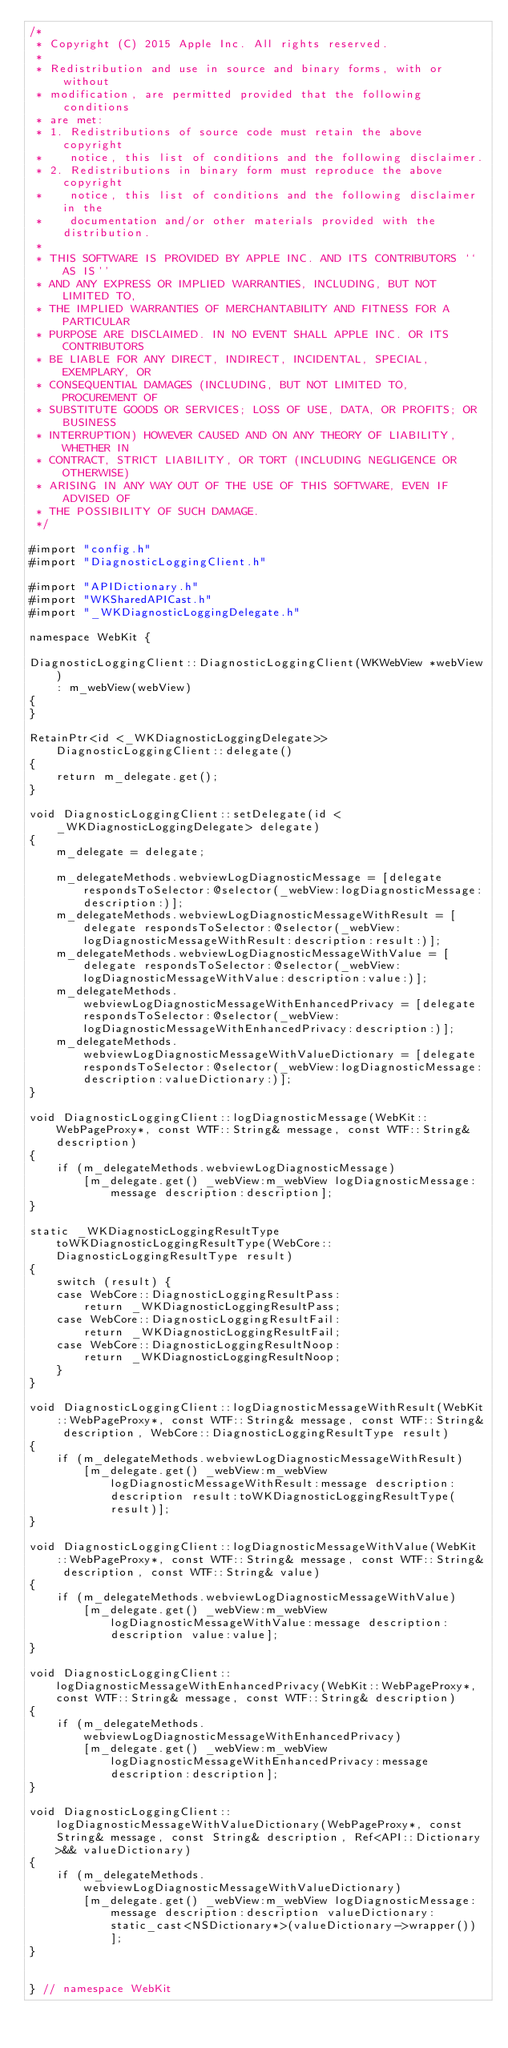<code> <loc_0><loc_0><loc_500><loc_500><_ObjectiveC_>/*
 * Copyright (C) 2015 Apple Inc. All rights reserved.
 *
 * Redistribution and use in source and binary forms, with or without
 * modification, are permitted provided that the following conditions
 * are met:
 * 1. Redistributions of source code must retain the above copyright
 *    notice, this list of conditions and the following disclaimer.
 * 2. Redistributions in binary form must reproduce the above copyright
 *    notice, this list of conditions and the following disclaimer in the
 *    documentation and/or other materials provided with the distribution.
 *
 * THIS SOFTWARE IS PROVIDED BY APPLE INC. AND ITS CONTRIBUTORS ``AS IS''
 * AND ANY EXPRESS OR IMPLIED WARRANTIES, INCLUDING, BUT NOT LIMITED TO,
 * THE IMPLIED WARRANTIES OF MERCHANTABILITY AND FITNESS FOR A PARTICULAR
 * PURPOSE ARE DISCLAIMED. IN NO EVENT SHALL APPLE INC. OR ITS CONTRIBUTORS
 * BE LIABLE FOR ANY DIRECT, INDIRECT, INCIDENTAL, SPECIAL, EXEMPLARY, OR
 * CONSEQUENTIAL DAMAGES (INCLUDING, BUT NOT LIMITED TO, PROCUREMENT OF
 * SUBSTITUTE GOODS OR SERVICES; LOSS OF USE, DATA, OR PROFITS; OR BUSINESS
 * INTERRUPTION) HOWEVER CAUSED AND ON ANY THEORY OF LIABILITY, WHETHER IN
 * CONTRACT, STRICT LIABILITY, OR TORT (INCLUDING NEGLIGENCE OR OTHERWISE)
 * ARISING IN ANY WAY OUT OF THE USE OF THIS SOFTWARE, EVEN IF ADVISED OF
 * THE POSSIBILITY OF SUCH DAMAGE.
 */

#import "config.h"
#import "DiagnosticLoggingClient.h"

#import "APIDictionary.h"
#import "WKSharedAPICast.h"
#import "_WKDiagnosticLoggingDelegate.h"

namespace WebKit {

DiagnosticLoggingClient::DiagnosticLoggingClient(WKWebView *webView)
    : m_webView(webView)
{
}

RetainPtr<id <_WKDiagnosticLoggingDelegate>> DiagnosticLoggingClient::delegate()
{
    return m_delegate.get();
}

void DiagnosticLoggingClient::setDelegate(id <_WKDiagnosticLoggingDelegate> delegate)
{
    m_delegate = delegate;

    m_delegateMethods.webviewLogDiagnosticMessage = [delegate respondsToSelector:@selector(_webView:logDiagnosticMessage:description:)];
    m_delegateMethods.webviewLogDiagnosticMessageWithResult = [delegate respondsToSelector:@selector(_webView:logDiagnosticMessageWithResult:description:result:)];
    m_delegateMethods.webviewLogDiagnosticMessageWithValue = [delegate respondsToSelector:@selector(_webView:logDiagnosticMessageWithValue:description:value:)];
    m_delegateMethods.webviewLogDiagnosticMessageWithEnhancedPrivacy = [delegate respondsToSelector:@selector(_webView:logDiagnosticMessageWithEnhancedPrivacy:description:)];
    m_delegateMethods.webviewLogDiagnosticMessageWithValueDictionary = [delegate respondsToSelector:@selector(_webView:logDiagnosticMessage:description:valueDictionary:)];
}

void DiagnosticLoggingClient::logDiagnosticMessage(WebKit::WebPageProxy*, const WTF::String& message, const WTF::String& description)
{
    if (m_delegateMethods.webviewLogDiagnosticMessage)
        [m_delegate.get() _webView:m_webView logDiagnosticMessage:message description:description];
}

static _WKDiagnosticLoggingResultType toWKDiagnosticLoggingResultType(WebCore::DiagnosticLoggingResultType result)
{
    switch (result) {
    case WebCore::DiagnosticLoggingResultPass:
        return _WKDiagnosticLoggingResultPass;
    case WebCore::DiagnosticLoggingResultFail:
        return _WKDiagnosticLoggingResultFail;
    case WebCore::DiagnosticLoggingResultNoop:
        return _WKDiagnosticLoggingResultNoop;
    }
}

void DiagnosticLoggingClient::logDiagnosticMessageWithResult(WebKit::WebPageProxy*, const WTF::String& message, const WTF::String& description, WebCore::DiagnosticLoggingResultType result)
{
    if (m_delegateMethods.webviewLogDiagnosticMessageWithResult)
        [m_delegate.get() _webView:m_webView logDiagnosticMessageWithResult:message description:description result:toWKDiagnosticLoggingResultType(result)];
}

void DiagnosticLoggingClient::logDiagnosticMessageWithValue(WebKit::WebPageProxy*, const WTF::String& message, const WTF::String& description, const WTF::String& value)
{
    if (m_delegateMethods.webviewLogDiagnosticMessageWithValue)
        [m_delegate.get() _webView:m_webView logDiagnosticMessageWithValue:message description:description value:value];
}

void DiagnosticLoggingClient::logDiagnosticMessageWithEnhancedPrivacy(WebKit::WebPageProxy*, const WTF::String& message, const WTF::String& description)
{
    if (m_delegateMethods.webviewLogDiagnosticMessageWithEnhancedPrivacy)
        [m_delegate.get() _webView:m_webView logDiagnosticMessageWithEnhancedPrivacy:message description:description];
}

void DiagnosticLoggingClient::logDiagnosticMessageWithValueDictionary(WebPageProxy*, const String& message, const String& description, Ref<API::Dictionary>&& valueDictionary)
{
    if (m_delegateMethods.webviewLogDiagnosticMessageWithValueDictionary)
        [m_delegate.get() _webView:m_webView logDiagnosticMessage:message description:description valueDictionary:static_cast<NSDictionary*>(valueDictionary->wrapper())];
}


} // namespace WebKit
</code> 